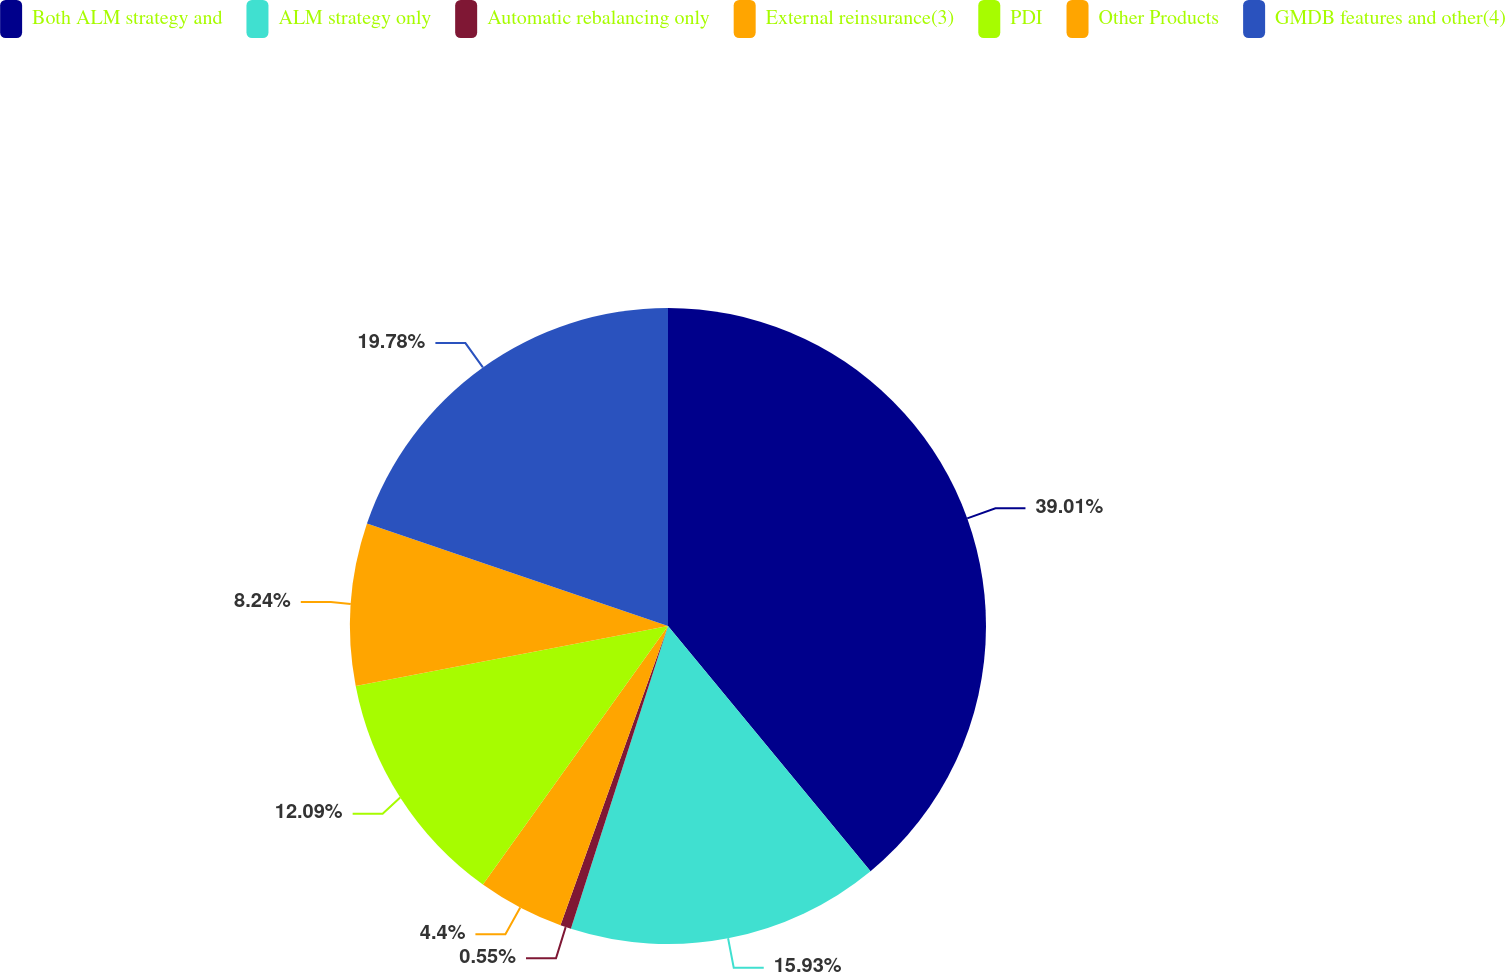Convert chart to OTSL. <chart><loc_0><loc_0><loc_500><loc_500><pie_chart><fcel>Both ALM strategy and<fcel>ALM strategy only<fcel>Automatic rebalancing only<fcel>External reinsurance(3)<fcel>PDI<fcel>Other Products<fcel>GMDB features and other(4)<nl><fcel>39.01%<fcel>15.93%<fcel>0.55%<fcel>4.4%<fcel>12.09%<fcel>8.24%<fcel>19.78%<nl></chart> 